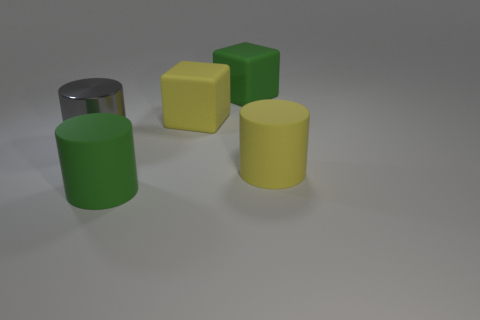How many big matte objects are both right of the big yellow cube and to the left of the big yellow rubber cylinder?
Provide a short and direct response. 1. Is there anything else that has the same material as the large gray object?
Ensure brevity in your answer.  No. Are there the same number of big rubber cylinders that are on the left side of the large green cylinder and matte objects that are behind the yellow matte cylinder?
Provide a short and direct response. No. Are the green cylinder and the big gray object made of the same material?
Your answer should be compact. No. What number of yellow things are either big cylinders or large rubber objects?
Provide a succinct answer. 2. How many other gray objects have the same shape as the large shiny thing?
Keep it short and to the point. 0. What is the large green cube made of?
Ensure brevity in your answer.  Rubber. Is the number of large gray metallic cylinders that are behind the metallic object the same as the number of small yellow balls?
Provide a short and direct response. Yes. There is a yellow object that is the same size as the yellow rubber cylinder; what is its shape?
Offer a terse response. Cube. Are there any big rubber cylinders that are right of the green rubber object behind the large gray object?
Provide a succinct answer. Yes. 